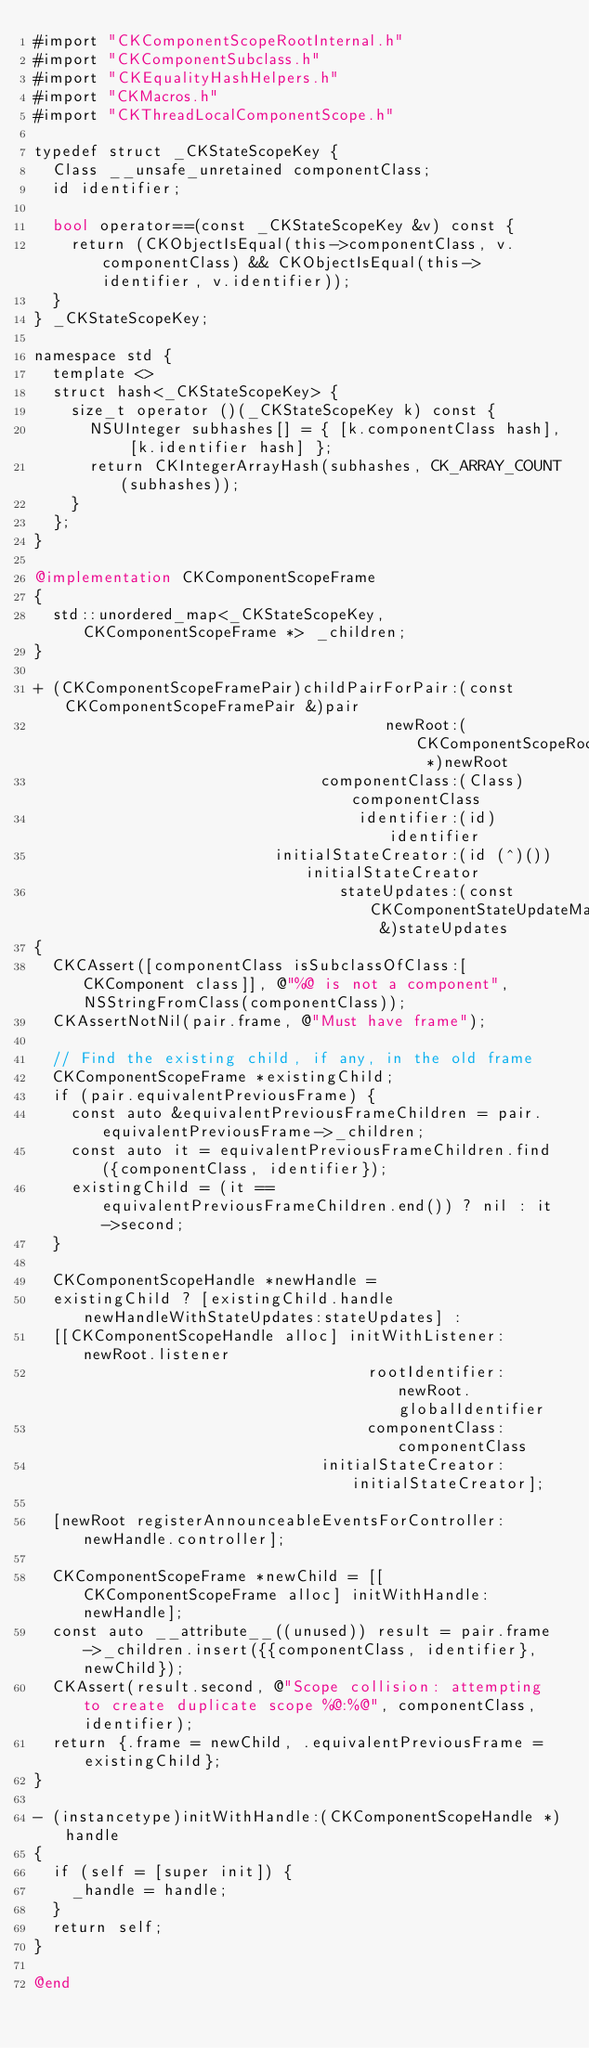<code> <loc_0><loc_0><loc_500><loc_500><_ObjectiveC_>#import "CKComponentScopeRootInternal.h"
#import "CKComponentSubclass.h"
#import "CKEqualityHashHelpers.h"
#import "CKMacros.h"
#import "CKThreadLocalComponentScope.h"

typedef struct _CKStateScopeKey {
  Class __unsafe_unretained componentClass;
  id identifier;

  bool operator==(const _CKStateScopeKey &v) const {
    return (CKObjectIsEqual(this->componentClass, v.componentClass) && CKObjectIsEqual(this->identifier, v.identifier));
  }
} _CKStateScopeKey;

namespace std {
  template <>
  struct hash<_CKStateScopeKey> {
    size_t operator ()(_CKStateScopeKey k) const {
      NSUInteger subhashes[] = { [k.componentClass hash], [k.identifier hash] };
      return CKIntegerArrayHash(subhashes, CK_ARRAY_COUNT(subhashes));
    }
  };
}

@implementation CKComponentScopeFrame
{
  std::unordered_map<_CKStateScopeKey, CKComponentScopeFrame *> _children;
}

+ (CKComponentScopeFramePair)childPairForPair:(const CKComponentScopeFramePair &)pair
                                      newRoot:(CKComponentScopeRoot *)newRoot
                               componentClass:(Class)componentClass
                                   identifier:(id)identifier
                          initialStateCreator:(id (^)())initialStateCreator
                                 stateUpdates:(const CKComponentStateUpdateMap &)stateUpdates
{
  CKCAssert([componentClass isSubclassOfClass:[CKComponent class]], @"%@ is not a component", NSStringFromClass(componentClass));
  CKAssertNotNil(pair.frame, @"Must have frame");

  // Find the existing child, if any, in the old frame
  CKComponentScopeFrame *existingChild;
  if (pair.equivalentPreviousFrame) {
    const auto &equivalentPreviousFrameChildren = pair.equivalentPreviousFrame->_children;
    const auto it = equivalentPreviousFrameChildren.find({componentClass, identifier});
    existingChild = (it == equivalentPreviousFrameChildren.end()) ? nil : it->second;
  }

  CKComponentScopeHandle *newHandle =
  existingChild ? [existingChild.handle newHandleWithStateUpdates:stateUpdates] :
  [[CKComponentScopeHandle alloc] initWithListener:newRoot.listener
                                    rootIdentifier:newRoot.globalIdentifier
                                    componentClass:componentClass
                               initialStateCreator:initialStateCreator];

  [newRoot registerAnnounceableEventsForController:newHandle.controller];

  CKComponentScopeFrame *newChild = [[CKComponentScopeFrame alloc] initWithHandle:newHandle];
  const auto __attribute__((unused)) result = pair.frame->_children.insert({{componentClass, identifier}, newChild});
  CKAssert(result.second, @"Scope collision: attempting to create duplicate scope %@:%@", componentClass, identifier);
  return {.frame = newChild, .equivalentPreviousFrame = existingChild};
}

- (instancetype)initWithHandle:(CKComponentScopeHandle *)handle
{
  if (self = [super init]) {
    _handle = handle;
  }
  return self;
}

@end
</code> 